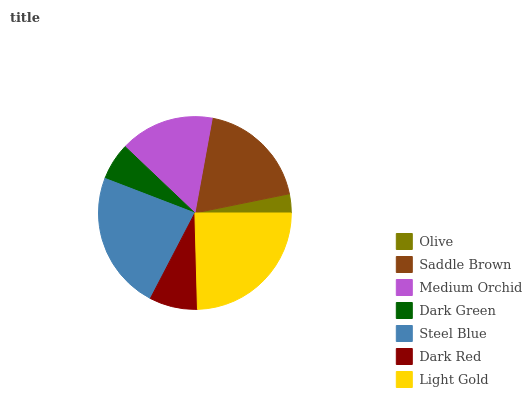Is Olive the minimum?
Answer yes or no. Yes. Is Light Gold the maximum?
Answer yes or no. Yes. Is Saddle Brown the minimum?
Answer yes or no. No. Is Saddle Brown the maximum?
Answer yes or no. No. Is Saddle Brown greater than Olive?
Answer yes or no. Yes. Is Olive less than Saddle Brown?
Answer yes or no. Yes. Is Olive greater than Saddle Brown?
Answer yes or no. No. Is Saddle Brown less than Olive?
Answer yes or no. No. Is Medium Orchid the high median?
Answer yes or no. Yes. Is Medium Orchid the low median?
Answer yes or no. Yes. Is Saddle Brown the high median?
Answer yes or no. No. Is Saddle Brown the low median?
Answer yes or no. No. 